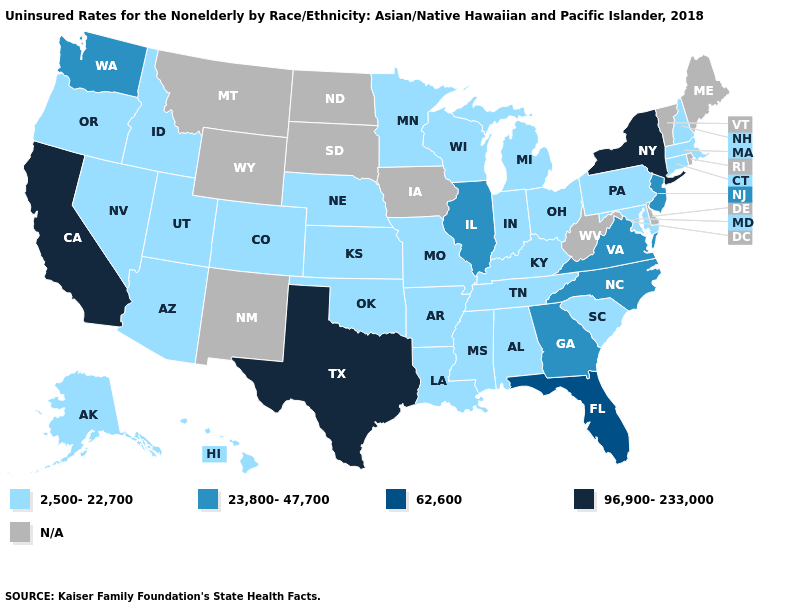Does California have the highest value in the USA?
Short answer required. Yes. What is the highest value in states that border Michigan?
Keep it brief. 2,500-22,700. How many symbols are there in the legend?
Quick response, please. 5. Name the states that have a value in the range 62,600?
Give a very brief answer. Florida. Among the states that border New Mexico , which have the lowest value?
Short answer required. Arizona, Colorado, Oklahoma, Utah. What is the highest value in the USA?
Quick response, please. 96,900-233,000. Does California have the lowest value in the USA?
Give a very brief answer. No. Name the states that have a value in the range 2,500-22,700?
Be succinct. Alabama, Alaska, Arizona, Arkansas, Colorado, Connecticut, Hawaii, Idaho, Indiana, Kansas, Kentucky, Louisiana, Maryland, Massachusetts, Michigan, Minnesota, Mississippi, Missouri, Nebraska, Nevada, New Hampshire, Ohio, Oklahoma, Oregon, Pennsylvania, South Carolina, Tennessee, Utah, Wisconsin. What is the value of Michigan?
Short answer required. 2,500-22,700. Does New York have the highest value in the Northeast?
Give a very brief answer. Yes. Name the states that have a value in the range 23,800-47,700?
Quick response, please. Georgia, Illinois, New Jersey, North Carolina, Virginia, Washington. 